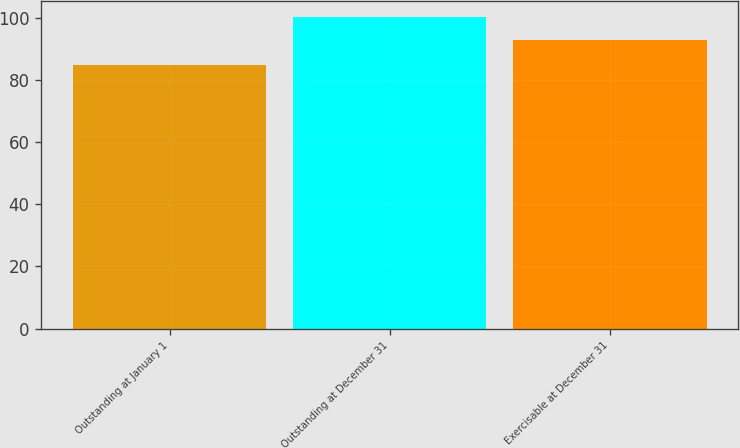<chart> <loc_0><loc_0><loc_500><loc_500><bar_chart><fcel>Outstanding at January 1<fcel>Outstanding at December 31<fcel>Exercisable at December 31<nl><fcel>84.85<fcel>100.38<fcel>92.72<nl></chart> 